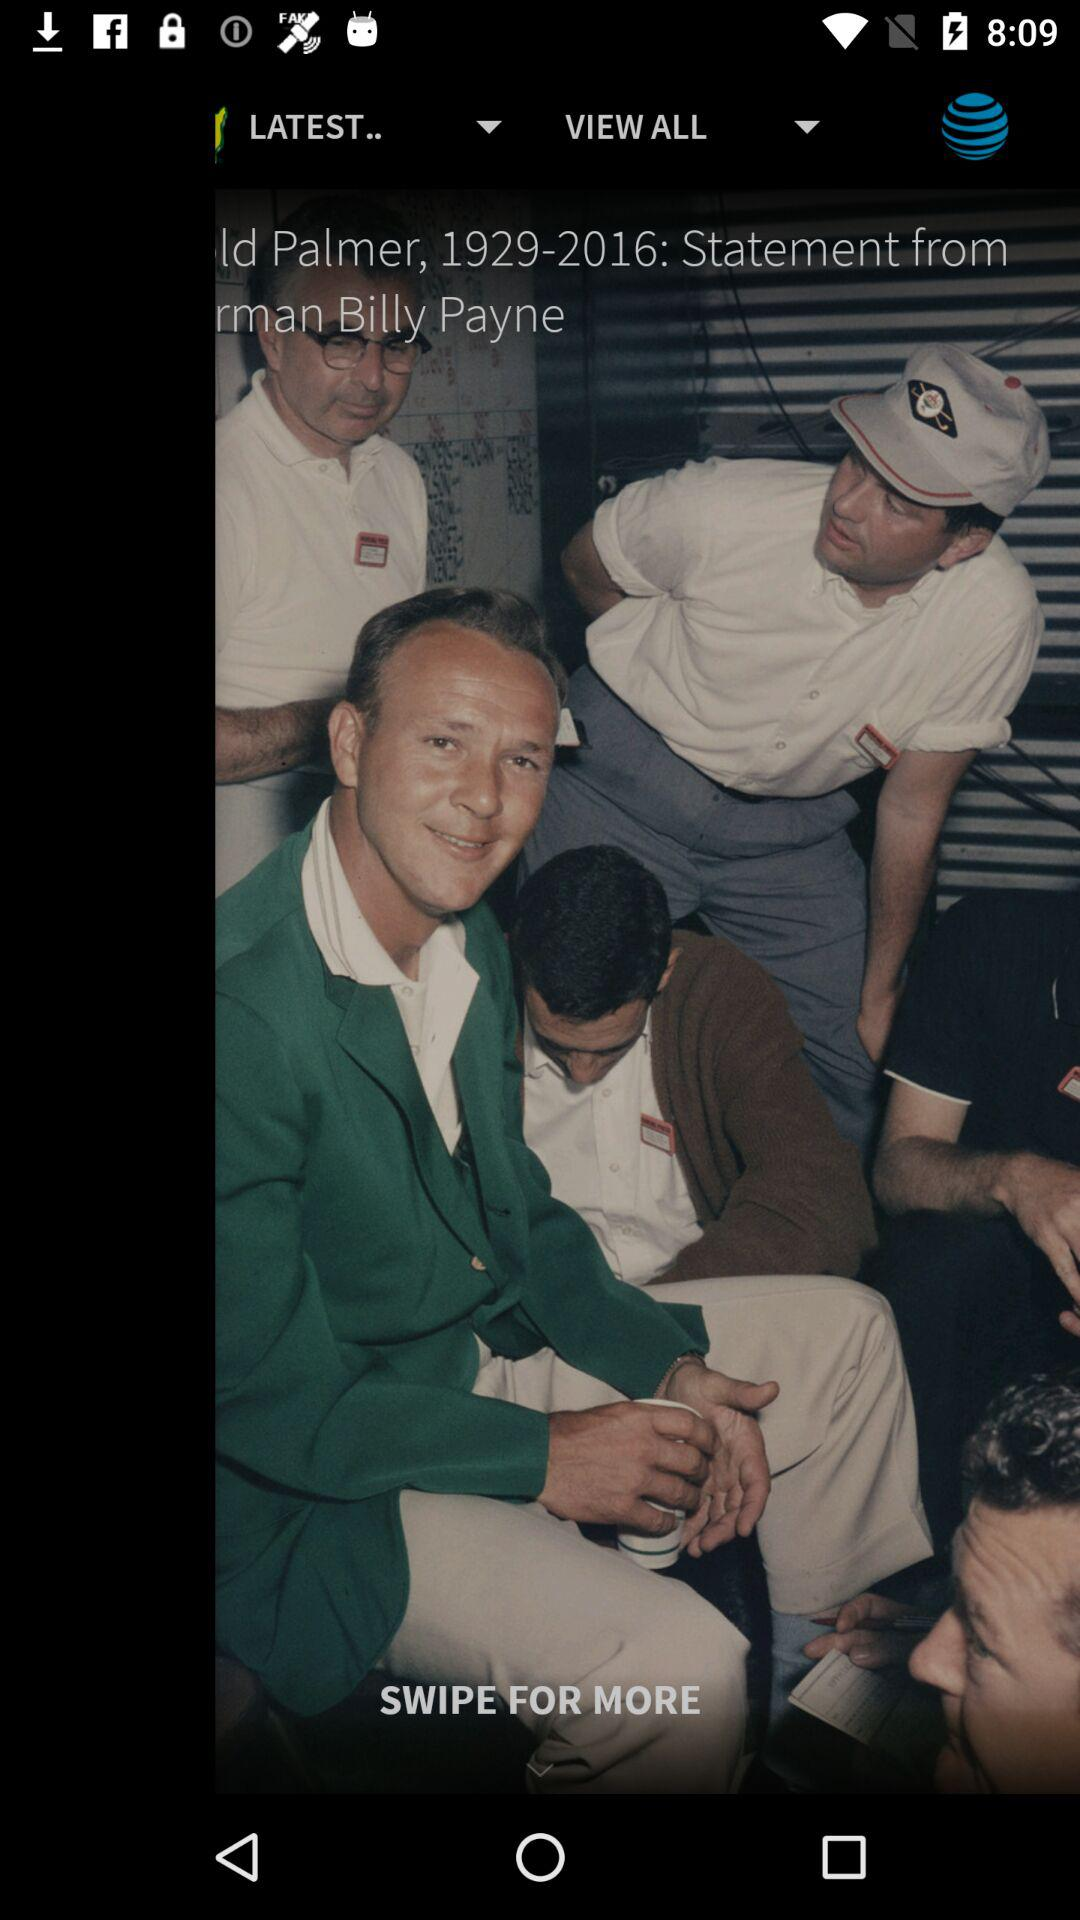How many shots are there in this round?
Answer the question using a single word or phrase. 4 